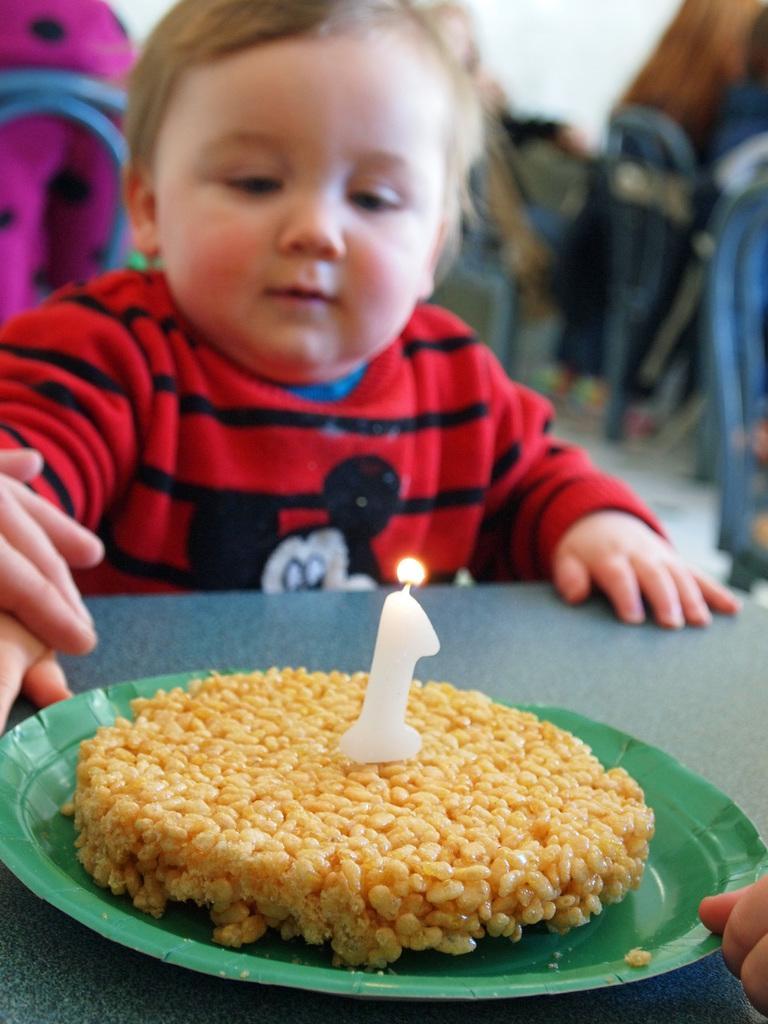Can you describe this image briefly? In this image I can see food item and a candle on the plate, which is placed on the table. There is a kid and there are fingers of a person. And the background is blurry. 